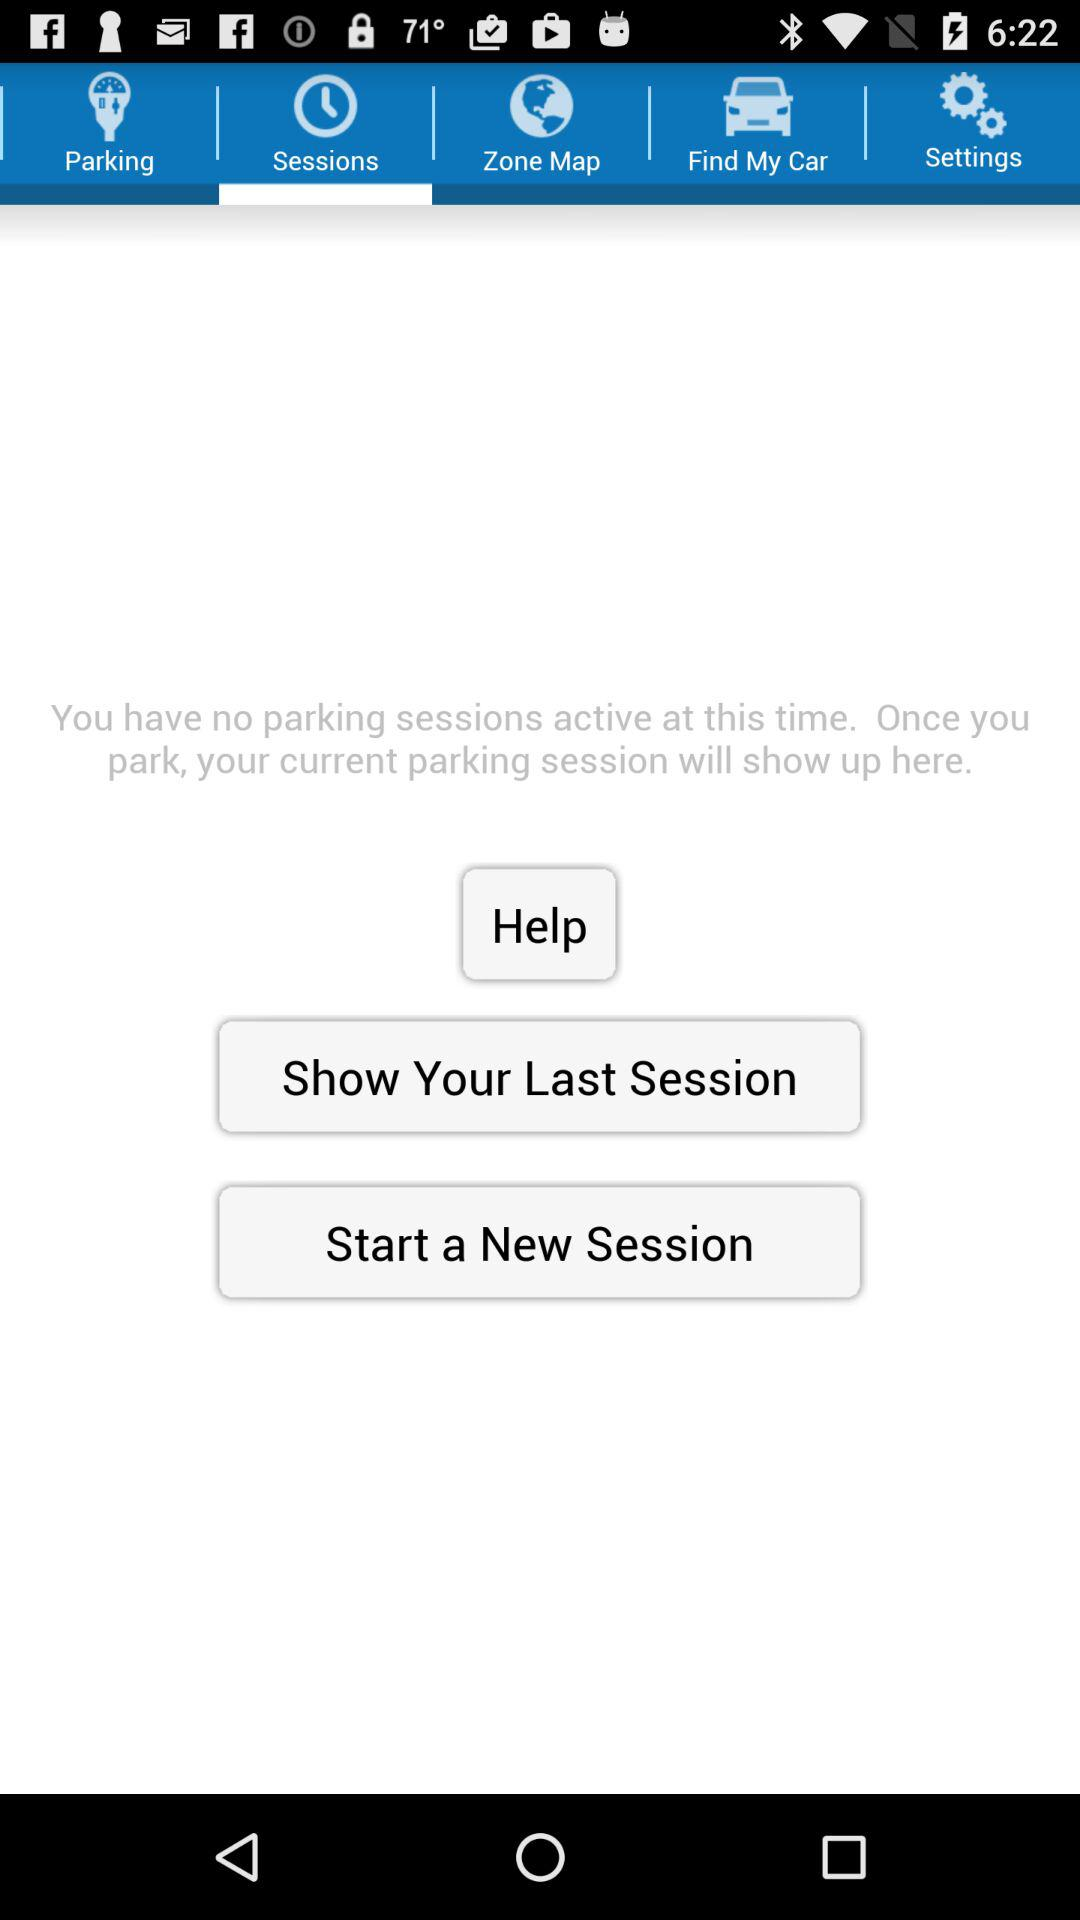Which tab is selected? The selected tab is "Sessions". 